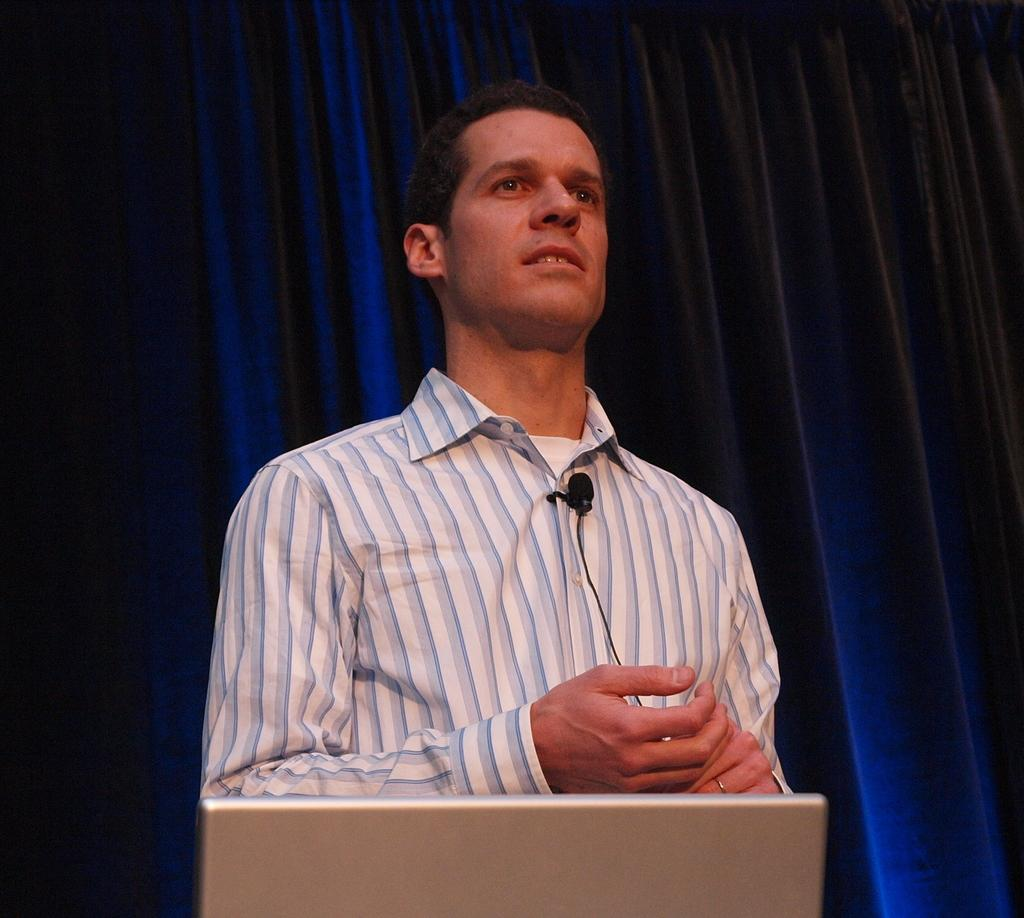What is the main subject of the image? There is a person standing in the image. What can be seen attached to the person's shirt? The person is wearing a microphone attached to their shirt. What electronic device is visible at the bottom of the image? There is a laptop visible at the bottom of the image. What type of covering is behind the person? There is a curtain behind the person. What type of milk is being poured into the plants in the image? There are no plants or milk present in the image. In which direction is the person facing in the image? The direction the person is facing cannot be determined from the image alone, as we cannot see their full body or the surrounding environment. 